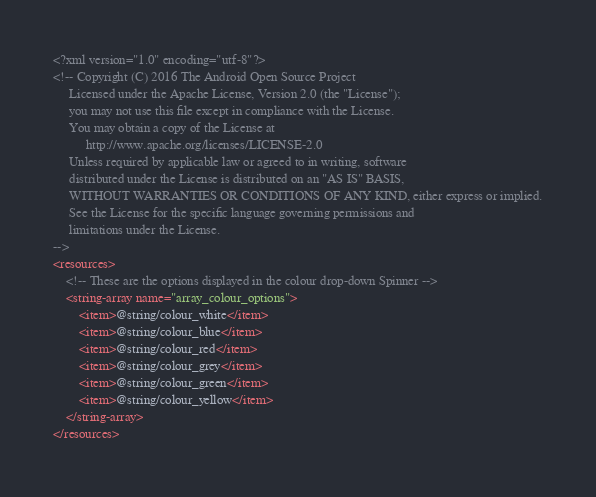Convert code to text. <code><loc_0><loc_0><loc_500><loc_500><_XML_><?xml version="1.0" encoding="utf-8"?>
<!-- Copyright (C) 2016 The Android Open Source Project
     Licensed under the Apache License, Version 2.0 (the "License");
     you may not use this file except in compliance with the License.
     You may obtain a copy of the License at
          http://www.apache.org/licenses/LICENSE-2.0
     Unless required by applicable law or agreed to in writing, software
     distributed under the License is distributed on an "AS IS" BASIS,
     WITHOUT WARRANTIES OR CONDITIONS OF ANY KIND, either express or implied.
     See the License for the specific language governing permissions and
     limitations under the License.
-->
<resources>
    <!-- These are the options displayed in the colour drop-down Spinner -->
    <string-array name="array_colour_options">
        <item>@string/colour_white</item>
        <item>@string/colour_blue</item>
        <item>@string/colour_red</item>
        <item>@string/colour_grey</item>
        <item>@string/colour_green</item>
        <item>@string/colour_yellow</item>
    </string-array>
</resources></code> 